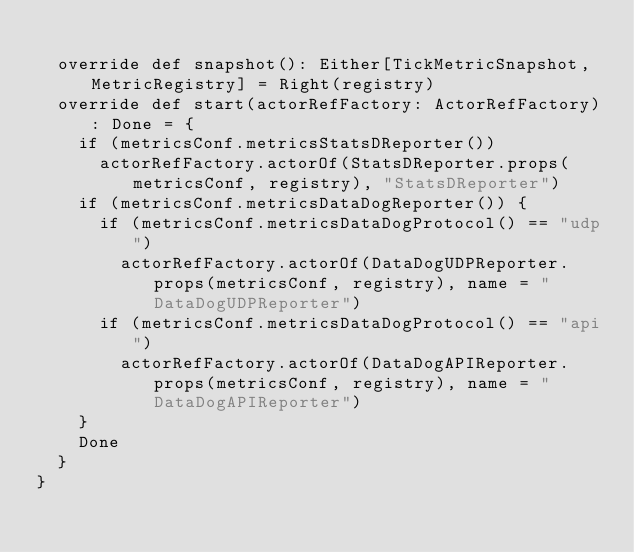<code> <loc_0><loc_0><loc_500><loc_500><_Scala_>
  override def snapshot(): Either[TickMetricSnapshot, MetricRegistry] = Right(registry)
  override def start(actorRefFactory: ActorRefFactory): Done = {
    if (metricsConf.metricsStatsDReporter())
      actorRefFactory.actorOf(StatsDReporter.props(metricsConf, registry), "StatsDReporter")
    if (metricsConf.metricsDataDogReporter()) {
      if (metricsConf.metricsDataDogProtocol() == "udp")
        actorRefFactory.actorOf(DataDogUDPReporter.props(metricsConf, registry), name = "DataDogUDPReporter")
      if (metricsConf.metricsDataDogProtocol() == "api")
        actorRefFactory.actorOf(DataDogAPIReporter.props(metricsConf, registry), name = "DataDogAPIReporter")
    }
    Done
  }
}
</code> 